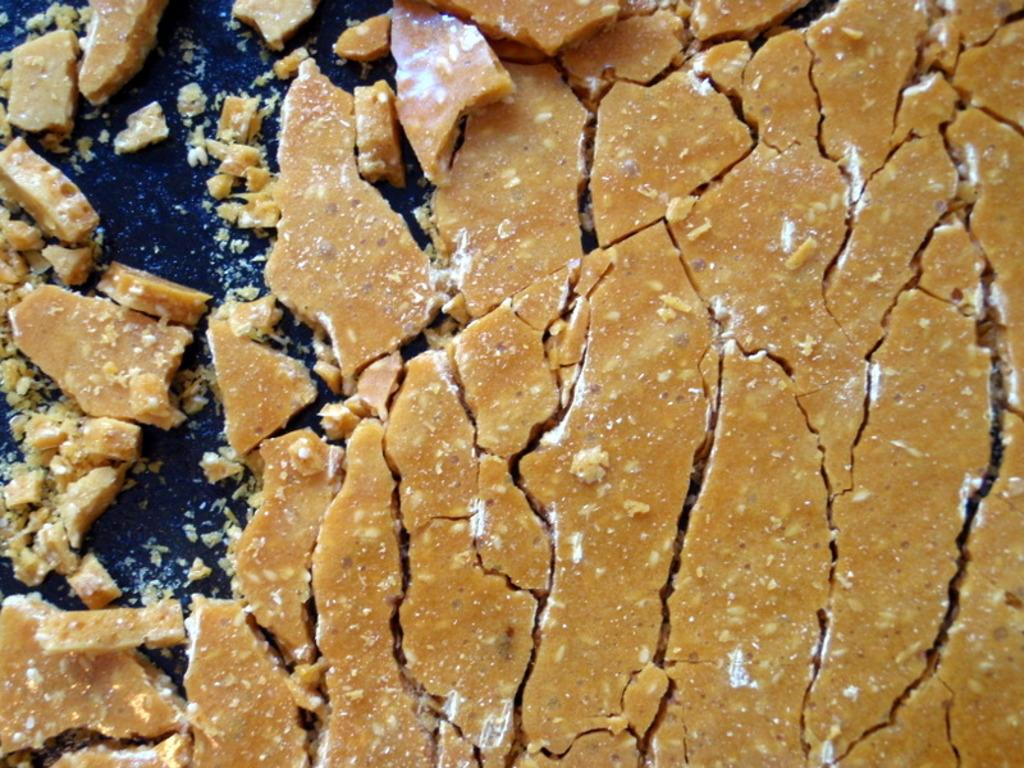What is the main subject of the image? There is a food item in the image. How is the food item being prepared or presented? The food item is on a pan. Are there any bears interacting with the food item on the pan in the image? No, there are no bears present in the image. 